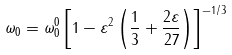Convert formula to latex. <formula><loc_0><loc_0><loc_500><loc_500>\omega _ { 0 } = \omega ^ { 0 } _ { 0 } \left [ 1 - \varepsilon ^ { 2 } \left ( \frac { 1 } { 3 } + \frac { 2 \varepsilon } { 2 7 } \right ) \right ] ^ { - 1 / 3 }</formula> 